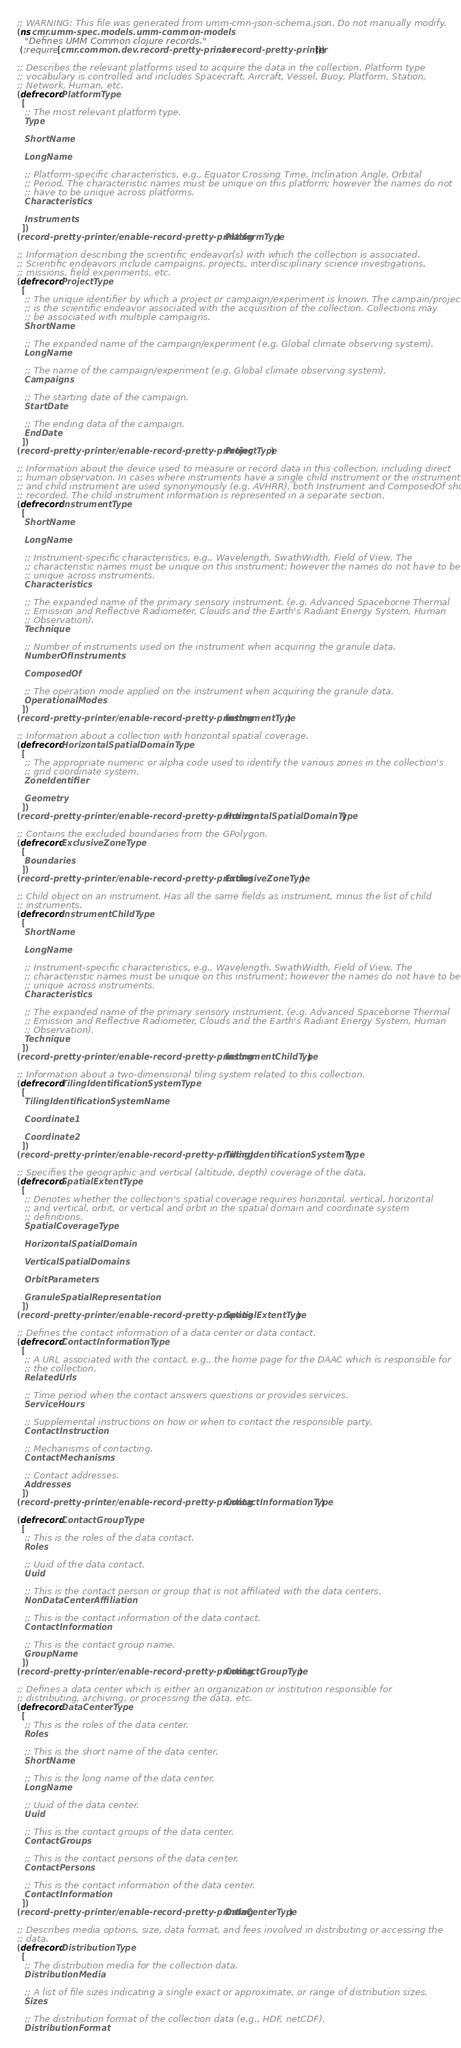<code> <loc_0><loc_0><loc_500><loc_500><_Clojure_>;; WARNING: This file was generated from umm-cmn-json-schema.json. Do not manually modify.
(ns cmr.umm-spec.models.umm-common-models
   "Defines UMM Common clojure records."
 (:require [cmr.common.dev.record-pretty-printer :as record-pretty-printer]))

;; Describes the relevant platforms used to acquire the data in the collection. Platform type
;; vocabulary is controlled and includes Spacecraft, Aircraft, Vessel, Buoy, Platform, Station,
;; Network, Human, etc.
(defrecord PlatformType
  [
   ;; The most relevant platform type.
   Type

   ShortName

   LongName

   ;; Platform-specific characteristics, e.g., Equator Crossing Time, Inclination Angle, Orbital
   ;; Period. The characteristic names must be unique on this platform; however the names do not
   ;; have to be unique across platforms.
   Characteristics

   Instruments
  ])
(record-pretty-printer/enable-record-pretty-printing PlatformType)

;; Information describing the scientific endeavor(s) with which the collection is associated.
;; Scientific endeavors include campaigns, projects, interdisciplinary science investigations,
;; missions, field experiments, etc.
(defrecord ProjectType
  [
   ;; The unique identifier by which a project or campaign/experiment is known. The campain/project
   ;; is the scientific endeavor associated with the acquisition of the collection. Collections may
   ;; be associated with multiple campaigns.
   ShortName

   ;; The expanded name of the campaign/experiment (e.g. Global climate observing system).
   LongName

   ;; The name of the campaign/experiment (e.g. Global climate observing system).
   Campaigns

   ;; The starting date of the campaign.
   StartDate

   ;; The ending data of the campaign.
   EndDate
  ])
(record-pretty-printer/enable-record-pretty-printing ProjectType)

;; Information about the device used to measure or record data in this collection, including direct
;; human observation. In cases where instruments have a single child instrument or the instrument
;; and child instrument are used synonymously (e.g. AVHRR), both Instrument and ComposedOf should be
;; recorded. The child instrument information is represented in a separate section.
(defrecord InstrumentType
  [
   ShortName

   LongName

   ;; Instrument-specific characteristics, e.g., Wavelength, SwathWidth, Field of View. The
   ;; characteristic names must be unique on this instrument; however the names do not have to be
   ;; unique across instruments.
   Characteristics

   ;; The expanded name of the primary sensory instrument. (e.g. Advanced Spaceborne Thermal
   ;; Emission and Reflective Radiometer, Clouds and the Earth's Radiant Energy System, Human
   ;; Observation).
   Technique

   ;; Number of instruments used on the instrument when acquiring the granule data.
   NumberOfInstruments

   ComposedOf

   ;; The operation mode applied on the instrument when acquiring the granule data.
   OperationalModes
  ])
(record-pretty-printer/enable-record-pretty-printing InstrumentType)

;; Information about a collection with horizontal spatial coverage.
(defrecord HorizontalSpatialDomainType
  [
   ;; The appropriate numeric or alpha code used to identify the various zones in the collection's
   ;; grid coordinate system.
   ZoneIdentifier

   Geometry
  ])
(record-pretty-printer/enable-record-pretty-printing HorizontalSpatialDomainType)

;; Contains the excluded boundaries from the GPolygon.
(defrecord ExclusiveZoneType
  [
   Boundaries
  ])
(record-pretty-printer/enable-record-pretty-printing ExclusiveZoneType)

;; Child object on an instrument. Has all the same fields as instrument, minus the list of child
;; instruments.
(defrecord InstrumentChildType
  [
   ShortName

   LongName

   ;; Instrument-specific characteristics, e.g., Wavelength, SwathWidth, Field of View. The
   ;; characteristic names must be unique on this instrument; however the names do not have to be
   ;; unique across instruments.
   Characteristics

   ;; The expanded name of the primary sensory instrument. (e.g. Advanced Spaceborne Thermal
   ;; Emission and Reflective Radiometer, Clouds and the Earth's Radiant Energy System, Human
   ;; Observation).
   Technique
  ])
(record-pretty-printer/enable-record-pretty-printing InstrumentChildType)

;; Information about a two-dimensional tiling system related to this collection.
(defrecord TilingIdentificationSystemType
  [
   TilingIdentificationSystemName

   Coordinate1

   Coordinate2
  ])
(record-pretty-printer/enable-record-pretty-printing TilingIdentificationSystemType)

;; Specifies the geographic and vertical (altitude, depth) coverage of the data.
(defrecord SpatialExtentType
  [
   ;; Denotes whether the collection's spatial coverage requires horizontal, vertical, horizontal
   ;; and vertical, orbit, or vertical and orbit in the spatial domain and coordinate system
   ;; definitions.
   SpatialCoverageType

   HorizontalSpatialDomain

   VerticalSpatialDomains

   OrbitParameters

   GranuleSpatialRepresentation
  ])
(record-pretty-printer/enable-record-pretty-printing SpatialExtentType)

;; Defines the contact information of a data center or data contact.
(defrecord ContactInformationType
  [
   ;; A URL associated with the contact, e.g., the home page for the DAAC which is responsible for
   ;; the collection.
   RelatedUrls

   ;; Time period when the contact answers questions or provides services.
   ServiceHours

   ;; Supplemental instructions on how or when to contact the responsible party.
   ContactInstruction

   ;; Mechanisms of contacting.
   ContactMechanisms

   ;; Contact addresses.
   Addresses
  ])
(record-pretty-printer/enable-record-pretty-printing ContactInformationType)

(defrecord ContactGroupType
  [
   ;; This is the roles of the data contact.
   Roles

   ;; Uuid of the data contact.
   Uuid

   ;; This is the contact person or group that is not affiliated with the data centers.
   NonDataCenterAffiliation

   ;; This is the contact information of the data contact.
   ContactInformation

   ;; This is the contact group name.
   GroupName
  ])
(record-pretty-printer/enable-record-pretty-printing ContactGroupType)

;; Defines a data center which is either an organization or institution responsible for
;; distributing, archiving, or processing the data, etc.
(defrecord DataCenterType
  [
   ;; This is the roles of the data center.
   Roles

   ;; This is the short name of the data center.
   ShortName

   ;; This is the long name of the data center.
   LongName

   ;; Uuid of the data center.
   Uuid

   ;; This is the contact groups of the data center.
   ContactGroups

   ;; This is the contact persons of the data center.
   ContactPersons

   ;; This is the contact information of the data center.
   ContactInformation
  ])
(record-pretty-printer/enable-record-pretty-printing DataCenterType)

;; Describes media options, size, data format, and fees involved in distributing or accessing the
;; data.
(defrecord DistributionType
  [
   ;; The distribution media for the collection data.
   DistributionMedia

   ;; A list of file sizes indicating a single exact or approximate, or range of distribution sizes.
   Sizes

   ;; The distribution format of the collection data (e.g., HDF, netCDF).
   DistributionFormat
</code> 